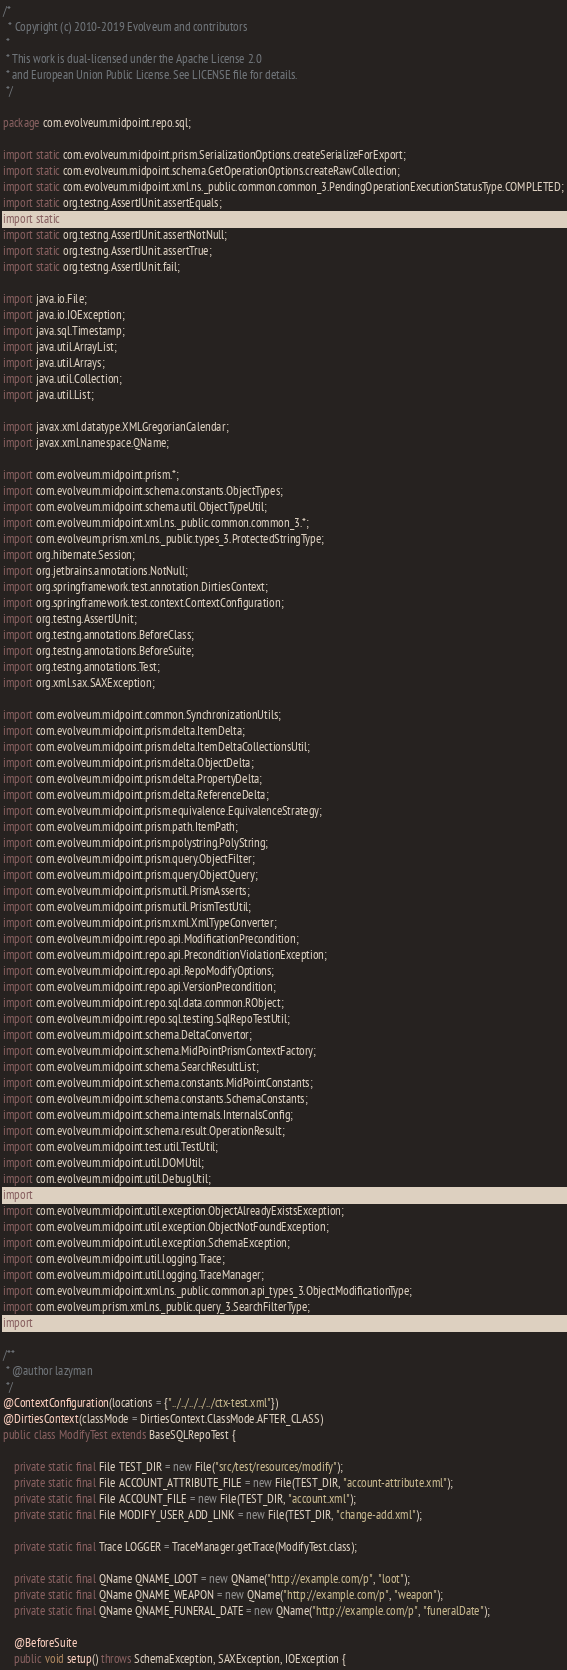<code> <loc_0><loc_0><loc_500><loc_500><_Java_>/*
  * Copyright (c) 2010-2019 Evolveum and contributors
 *
 * This work is dual-licensed under the Apache License 2.0
 * and European Union Public License. See LICENSE file for details.
 */

package com.evolveum.midpoint.repo.sql;

import static com.evolveum.midpoint.prism.SerializationOptions.createSerializeForExport;
import static com.evolveum.midpoint.schema.GetOperationOptions.createRawCollection;
import static com.evolveum.midpoint.xml.ns._public.common.common_3.PendingOperationExecutionStatusType.COMPLETED;
import static org.testng.AssertJUnit.assertEquals;
import static org.testng.AssertJUnit.assertFalse;
import static org.testng.AssertJUnit.assertNotNull;
import static org.testng.AssertJUnit.assertTrue;
import static org.testng.AssertJUnit.fail;

import java.io.File;
import java.io.IOException;
import java.sql.Timestamp;
import java.util.ArrayList;
import java.util.Arrays;
import java.util.Collection;
import java.util.List;

import javax.xml.datatype.XMLGregorianCalendar;
import javax.xml.namespace.QName;

import com.evolveum.midpoint.prism.*;
import com.evolveum.midpoint.schema.constants.ObjectTypes;
import com.evolveum.midpoint.schema.util.ObjectTypeUtil;
import com.evolveum.midpoint.xml.ns._public.common.common_3.*;
import com.evolveum.prism.xml.ns._public.types_3.ProtectedStringType;
import org.hibernate.Session;
import org.jetbrains.annotations.NotNull;
import org.springframework.test.annotation.DirtiesContext;
import org.springframework.test.context.ContextConfiguration;
import org.testng.AssertJUnit;
import org.testng.annotations.BeforeClass;
import org.testng.annotations.BeforeSuite;
import org.testng.annotations.Test;
import org.xml.sax.SAXException;

import com.evolveum.midpoint.common.SynchronizationUtils;
import com.evolveum.midpoint.prism.delta.ItemDelta;
import com.evolveum.midpoint.prism.delta.ItemDeltaCollectionsUtil;
import com.evolveum.midpoint.prism.delta.ObjectDelta;
import com.evolveum.midpoint.prism.delta.PropertyDelta;
import com.evolveum.midpoint.prism.delta.ReferenceDelta;
import com.evolveum.midpoint.prism.equivalence.EquivalenceStrategy;
import com.evolveum.midpoint.prism.path.ItemPath;
import com.evolveum.midpoint.prism.polystring.PolyString;
import com.evolveum.midpoint.prism.query.ObjectFilter;
import com.evolveum.midpoint.prism.query.ObjectQuery;
import com.evolveum.midpoint.prism.util.PrismAsserts;
import com.evolveum.midpoint.prism.util.PrismTestUtil;
import com.evolveum.midpoint.prism.xml.XmlTypeConverter;
import com.evolveum.midpoint.repo.api.ModificationPrecondition;
import com.evolveum.midpoint.repo.api.PreconditionViolationException;
import com.evolveum.midpoint.repo.api.RepoModifyOptions;
import com.evolveum.midpoint.repo.api.VersionPrecondition;
import com.evolveum.midpoint.repo.sql.data.common.RObject;
import com.evolveum.midpoint.repo.sql.testing.SqlRepoTestUtil;
import com.evolveum.midpoint.schema.DeltaConvertor;
import com.evolveum.midpoint.schema.MidPointPrismContextFactory;
import com.evolveum.midpoint.schema.SearchResultList;
import com.evolveum.midpoint.schema.constants.MidPointConstants;
import com.evolveum.midpoint.schema.constants.SchemaConstants;
import com.evolveum.midpoint.schema.internals.InternalsConfig;
import com.evolveum.midpoint.schema.result.OperationResult;
import com.evolveum.midpoint.test.util.TestUtil;
import com.evolveum.midpoint.util.DOMUtil;
import com.evolveum.midpoint.util.DebugUtil;
import com.evolveum.midpoint.util.PrettyPrinter;
import com.evolveum.midpoint.util.exception.ObjectAlreadyExistsException;
import com.evolveum.midpoint.util.exception.ObjectNotFoundException;
import com.evolveum.midpoint.util.exception.SchemaException;
import com.evolveum.midpoint.util.logging.Trace;
import com.evolveum.midpoint.util.logging.TraceManager;
import com.evolveum.midpoint.xml.ns._public.common.api_types_3.ObjectModificationType;
import com.evolveum.prism.xml.ns._public.query_3.SearchFilterType;
import com.evolveum.prism.xml.ns._public.types_3.PolyStringType;

/**
 * @author lazyman
 */
@ContextConfiguration(locations = {"../../../../../ctx-test.xml"})
@DirtiesContext(classMode = DirtiesContext.ClassMode.AFTER_CLASS)
public class ModifyTest extends BaseSQLRepoTest {

    private static final File TEST_DIR = new File("src/test/resources/modify");
    private static final File ACCOUNT_ATTRIBUTE_FILE = new File(TEST_DIR, "account-attribute.xml");
    private static final File ACCOUNT_FILE = new File(TEST_DIR, "account.xml");
    private static final File MODIFY_USER_ADD_LINK = new File(TEST_DIR, "change-add.xml");

    private static final Trace LOGGER = TraceManager.getTrace(ModifyTest.class);

    private static final QName QNAME_LOOT = new QName("http://example.com/p", "loot");
    private static final QName QNAME_WEAPON = new QName("http://example.com/p", "weapon");
    private static final QName QNAME_FUNERAL_DATE = new QName("http://example.com/p", "funeralDate");

    @BeforeSuite
    public void setup() throws SchemaException, SAXException, IOException {</code> 